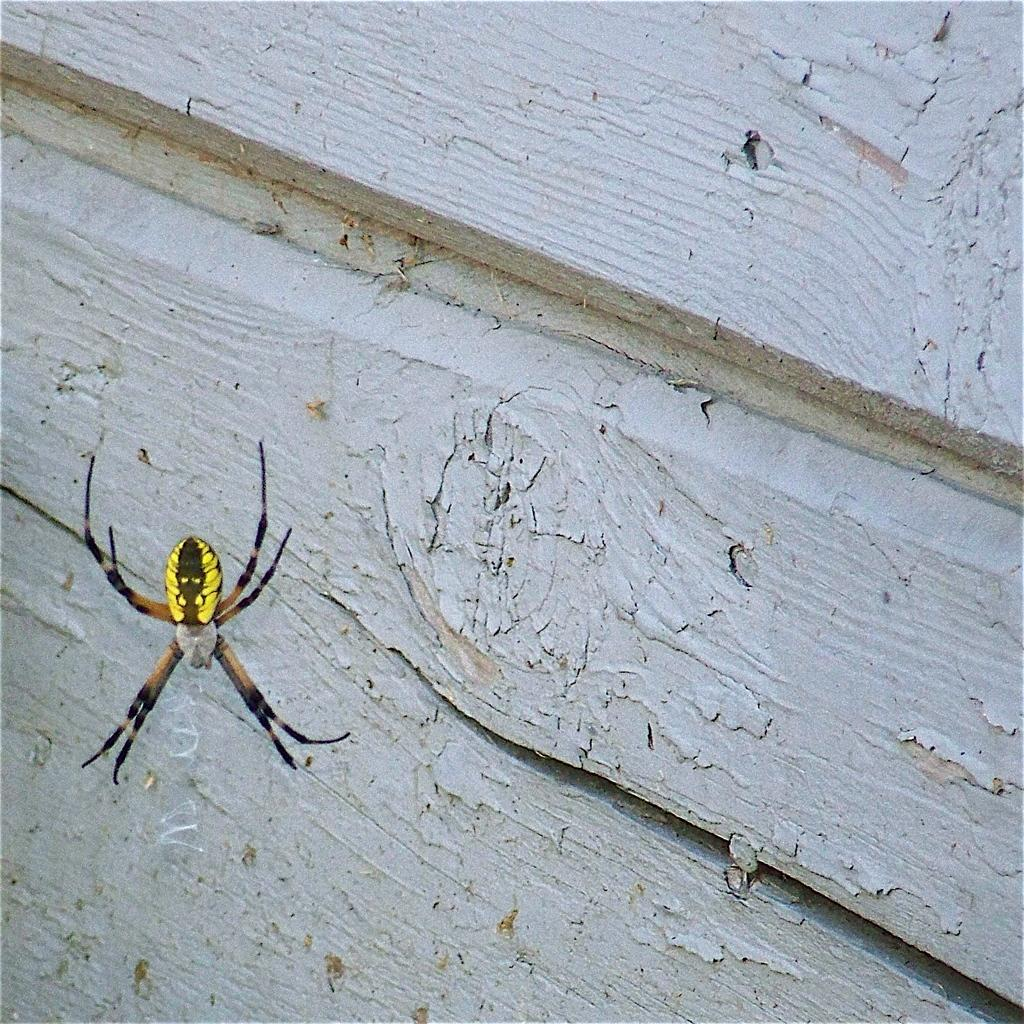What type of creature can be seen on the left side of the image? There is an insect on the left side of the image. What material is used to construct the wall in the image? The wall in the image is made of wood. What type of alley can be seen in the image? There is no alley present in the image; it only features an insect and a wooden wall. What view can be seen from the wooden wall in the image? The image does not provide a view from the wooden wall, as it only shows the wall itself and the insect. 